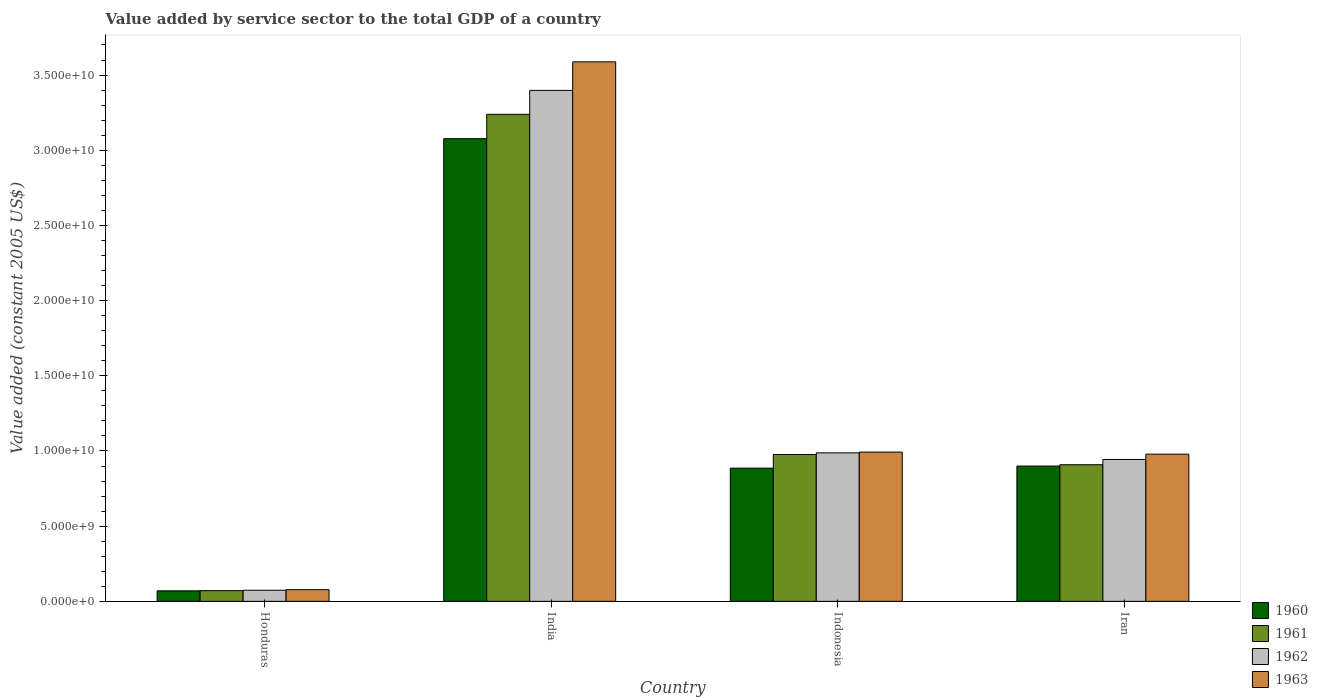How many different coloured bars are there?
Your response must be concise. 4. How many bars are there on the 2nd tick from the left?
Give a very brief answer. 4. How many bars are there on the 3rd tick from the right?
Ensure brevity in your answer.  4. What is the label of the 4th group of bars from the left?
Make the answer very short. Iran. What is the value added by service sector in 1962 in Honduras?
Keep it short and to the point. 7.41e+08. Across all countries, what is the maximum value added by service sector in 1960?
Provide a succinct answer. 3.08e+1. Across all countries, what is the minimum value added by service sector in 1961?
Your answer should be compact. 7.12e+08. In which country was the value added by service sector in 1960 minimum?
Make the answer very short. Honduras. What is the total value added by service sector in 1963 in the graph?
Give a very brief answer. 5.64e+1. What is the difference between the value added by service sector in 1960 in Honduras and that in India?
Provide a succinct answer. -3.01e+1. What is the difference between the value added by service sector in 1960 in India and the value added by service sector in 1961 in Honduras?
Your response must be concise. 3.01e+1. What is the average value added by service sector in 1960 per country?
Your answer should be compact. 1.23e+1. What is the difference between the value added by service sector of/in 1961 and value added by service sector of/in 1963 in Honduras?
Offer a terse response. -6.62e+07. In how many countries, is the value added by service sector in 1963 greater than 31000000000 US$?
Provide a succinct answer. 1. What is the ratio of the value added by service sector in 1961 in India to that in Iran?
Make the answer very short. 3.56. Is the value added by service sector in 1963 in Honduras less than that in Iran?
Provide a succinct answer. Yes. What is the difference between the highest and the second highest value added by service sector in 1961?
Your answer should be very brief. 2.26e+1. What is the difference between the highest and the lowest value added by service sector in 1963?
Offer a very short reply. 3.51e+1. In how many countries, is the value added by service sector in 1962 greater than the average value added by service sector in 1962 taken over all countries?
Provide a short and direct response. 1. What does the 3rd bar from the left in Honduras represents?
Your response must be concise. 1962. What does the 2nd bar from the right in Indonesia represents?
Offer a terse response. 1962. How many bars are there?
Make the answer very short. 16. What is the difference between two consecutive major ticks on the Y-axis?
Your answer should be compact. 5.00e+09. How many legend labels are there?
Make the answer very short. 4. How are the legend labels stacked?
Ensure brevity in your answer.  Vertical. What is the title of the graph?
Provide a short and direct response. Value added by service sector to the total GDP of a country. What is the label or title of the Y-axis?
Give a very brief answer. Value added (constant 2005 US$). What is the Value added (constant 2005 US$) of 1960 in Honduras?
Offer a terse response. 7.01e+08. What is the Value added (constant 2005 US$) of 1961 in Honduras?
Your answer should be very brief. 7.12e+08. What is the Value added (constant 2005 US$) in 1962 in Honduras?
Your answer should be compact. 7.41e+08. What is the Value added (constant 2005 US$) of 1963 in Honduras?
Give a very brief answer. 7.78e+08. What is the Value added (constant 2005 US$) in 1960 in India?
Offer a very short reply. 3.08e+1. What is the Value added (constant 2005 US$) of 1961 in India?
Your answer should be very brief. 3.24e+1. What is the Value added (constant 2005 US$) in 1962 in India?
Your response must be concise. 3.40e+1. What is the Value added (constant 2005 US$) of 1963 in India?
Offer a very short reply. 3.59e+1. What is the Value added (constant 2005 US$) in 1960 in Indonesia?
Ensure brevity in your answer.  8.86e+09. What is the Value added (constant 2005 US$) in 1961 in Indonesia?
Your response must be concise. 9.77e+09. What is the Value added (constant 2005 US$) of 1962 in Indonesia?
Give a very brief answer. 9.88e+09. What is the Value added (constant 2005 US$) in 1963 in Indonesia?
Keep it short and to the point. 9.93e+09. What is the Value added (constant 2005 US$) in 1960 in Iran?
Provide a short and direct response. 9.00e+09. What is the Value added (constant 2005 US$) of 1961 in Iran?
Your answer should be very brief. 9.09e+09. What is the Value added (constant 2005 US$) in 1962 in Iran?
Your answer should be very brief. 9.44e+09. What is the Value added (constant 2005 US$) of 1963 in Iran?
Offer a very short reply. 9.79e+09. Across all countries, what is the maximum Value added (constant 2005 US$) of 1960?
Ensure brevity in your answer.  3.08e+1. Across all countries, what is the maximum Value added (constant 2005 US$) in 1961?
Your answer should be very brief. 3.24e+1. Across all countries, what is the maximum Value added (constant 2005 US$) of 1962?
Provide a short and direct response. 3.40e+1. Across all countries, what is the maximum Value added (constant 2005 US$) in 1963?
Your response must be concise. 3.59e+1. Across all countries, what is the minimum Value added (constant 2005 US$) of 1960?
Your answer should be very brief. 7.01e+08. Across all countries, what is the minimum Value added (constant 2005 US$) in 1961?
Provide a succinct answer. 7.12e+08. Across all countries, what is the minimum Value added (constant 2005 US$) of 1962?
Offer a very short reply. 7.41e+08. Across all countries, what is the minimum Value added (constant 2005 US$) in 1963?
Offer a terse response. 7.78e+08. What is the total Value added (constant 2005 US$) of 1960 in the graph?
Make the answer very short. 4.93e+1. What is the total Value added (constant 2005 US$) in 1961 in the graph?
Make the answer very short. 5.20e+1. What is the total Value added (constant 2005 US$) in 1962 in the graph?
Your answer should be compact. 5.40e+1. What is the total Value added (constant 2005 US$) in 1963 in the graph?
Provide a short and direct response. 5.64e+1. What is the difference between the Value added (constant 2005 US$) in 1960 in Honduras and that in India?
Give a very brief answer. -3.01e+1. What is the difference between the Value added (constant 2005 US$) in 1961 in Honduras and that in India?
Your answer should be very brief. -3.17e+1. What is the difference between the Value added (constant 2005 US$) of 1962 in Honduras and that in India?
Offer a terse response. -3.32e+1. What is the difference between the Value added (constant 2005 US$) in 1963 in Honduras and that in India?
Provide a succinct answer. -3.51e+1. What is the difference between the Value added (constant 2005 US$) in 1960 in Honduras and that in Indonesia?
Give a very brief answer. -8.16e+09. What is the difference between the Value added (constant 2005 US$) in 1961 in Honduras and that in Indonesia?
Ensure brevity in your answer.  -9.05e+09. What is the difference between the Value added (constant 2005 US$) in 1962 in Honduras and that in Indonesia?
Your answer should be very brief. -9.13e+09. What is the difference between the Value added (constant 2005 US$) of 1963 in Honduras and that in Indonesia?
Offer a very short reply. -9.15e+09. What is the difference between the Value added (constant 2005 US$) in 1960 in Honduras and that in Iran?
Your response must be concise. -8.30e+09. What is the difference between the Value added (constant 2005 US$) in 1961 in Honduras and that in Iran?
Your answer should be compact. -8.37e+09. What is the difference between the Value added (constant 2005 US$) in 1962 in Honduras and that in Iran?
Your answer should be very brief. -8.70e+09. What is the difference between the Value added (constant 2005 US$) of 1963 in Honduras and that in Iran?
Give a very brief answer. -9.01e+09. What is the difference between the Value added (constant 2005 US$) of 1960 in India and that in Indonesia?
Offer a very short reply. 2.19e+1. What is the difference between the Value added (constant 2005 US$) in 1961 in India and that in Indonesia?
Your answer should be very brief. 2.26e+1. What is the difference between the Value added (constant 2005 US$) in 1962 in India and that in Indonesia?
Your response must be concise. 2.41e+1. What is the difference between the Value added (constant 2005 US$) in 1963 in India and that in Indonesia?
Offer a very short reply. 2.60e+1. What is the difference between the Value added (constant 2005 US$) of 1960 in India and that in Iran?
Make the answer very short. 2.18e+1. What is the difference between the Value added (constant 2005 US$) of 1961 in India and that in Iran?
Ensure brevity in your answer.  2.33e+1. What is the difference between the Value added (constant 2005 US$) in 1962 in India and that in Iran?
Provide a short and direct response. 2.45e+1. What is the difference between the Value added (constant 2005 US$) in 1963 in India and that in Iran?
Offer a very short reply. 2.61e+1. What is the difference between the Value added (constant 2005 US$) of 1960 in Indonesia and that in Iran?
Your answer should be very brief. -1.39e+08. What is the difference between the Value added (constant 2005 US$) of 1961 in Indonesia and that in Iran?
Provide a short and direct response. 6.80e+08. What is the difference between the Value added (constant 2005 US$) in 1962 in Indonesia and that in Iran?
Your answer should be very brief. 4.39e+08. What is the difference between the Value added (constant 2005 US$) of 1963 in Indonesia and that in Iran?
Give a very brief answer. 1.38e+08. What is the difference between the Value added (constant 2005 US$) of 1960 in Honduras and the Value added (constant 2005 US$) of 1961 in India?
Give a very brief answer. -3.17e+1. What is the difference between the Value added (constant 2005 US$) in 1960 in Honduras and the Value added (constant 2005 US$) in 1962 in India?
Your answer should be compact. -3.33e+1. What is the difference between the Value added (constant 2005 US$) of 1960 in Honduras and the Value added (constant 2005 US$) of 1963 in India?
Ensure brevity in your answer.  -3.52e+1. What is the difference between the Value added (constant 2005 US$) of 1961 in Honduras and the Value added (constant 2005 US$) of 1962 in India?
Ensure brevity in your answer.  -3.33e+1. What is the difference between the Value added (constant 2005 US$) in 1961 in Honduras and the Value added (constant 2005 US$) in 1963 in India?
Provide a short and direct response. -3.52e+1. What is the difference between the Value added (constant 2005 US$) of 1962 in Honduras and the Value added (constant 2005 US$) of 1963 in India?
Your response must be concise. -3.51e+1. What is the difference between the Value added (constant 2005 US$) of 1960 in Honduras and the Value added (constant 2005 US$) of 1961 in Indonesia?
Keep it short and to the point. -9.07e+09. What is the difference between the Value added (constant 2005 US$) in 1960 in Honduras and the Value added (constant 2005 US$) in 1962 in Indonesia?
Keep it short and to the point. -9.17e+09. What is the difference between the Value added (constant 2005 US$) in 1960 in Honduras and the Value added (constant 2005 US$) in 1963 in Indonesia?
Ensure brevity in your answer.  -9.23e+09. What is the difference between the Value added (constant 2005 US$) of 1961 in Honduras and the Value added (constant 2005 US$) of 1962 in Indonesia?
Give a very brief answer. -9.16e+09. What is the difference between the Value added (constant 2005 US$) in 1961 in Honduras and the Value added (constant 2005 US$) in 1963 in Indonesia?
Ensure brevity in your answer.  -9.22e+09. What is the difference between the Value added (constant 2005 US$) in 1962 in Honduras and the Value added (constant 2005 US$) in 1963 in Indonesia?
Offer a very short reply. -9.19e+09. What is the difference between the Value added (constant 2005 US$) in 1960 in Honduras and the Value added (constant 2005 US$) in 1961 in Iran?
Keep it short and to the point. -8.39e+09. What is the difference between the Value added (constant 2005 US$) of 1960 in Honduras and the Value added (constant 2005 US$) of 1962 in Iran?
Make the answer very short. -8.73e+09. What is the difference between the Value added (constant 2005 US$) in 1960 in Honduras and the Value added (constant 2005 US$) in 1963 in Iran?
Keep it short and to the point. -9.09e+09. What is the difference between the Value added (constant 2005 US$) of 1961 in Honduras and the Value added (constant 2005 US$) of 1962 in Iran?
Your response must be concise. -8.72e+09. What is the difference between the Value added (constant 2005 US$) in 1961 in Honduras and the Value added (constant 2005 US$) in 1963 in Iran?
Offer a terse response. -9.08e+09. What is the difference between the Value added (constant 2005 US$) of 1962 in Honduras and the Value added (constant 2005 US$) of 1963 in Iran?
Your answer should be compact. -9.05e+09. What is the difference between the Value added (constant 2005 US$) in 1960 in India and the Value added (constant 2005 US$) in 1961 in Indonesia?
Make the answer very short. 2.10e+1. What is the difference between the Value added (constant 2005 US$) of 1960 in India and the Value added (constant 2005 US$) of 1962 in Indonesia?
Your answer should be compact. 2.09e+1. What is the difference between the Value added (constant 2005 US$) of 1960 in India and the Value added (constant 2005 US$) of 1963 in Indonesia?
Provide a succinct answer. 2.08e+1. What is the difference between the Value added (constant 2005 US$) in 1961 in India and the Value added (constant 2005 US$) in 1962 in Indonesia?
Give a very brief answer. 2.25e+1. What is the difference between the Value added (constant 2005 US$) of 1961 in India and the Value added (constant 2005 US$) of 1963 in Indonesia?
Your response must be concise. 2.25e+1. What is the difference between the Value added (constant 2005 US$) of 1962 in India and the Value added (constant 2005 US$) of 1963 in Indonesia?
Your answer should be very brief. 2.41e+1. What is the difference between the Value added (constant 2005 US$) in 1960 in India and the Value added (constant 2005 US$) in 1961 in Iran?
Your answer should be very brief. 2.17e+1. What is the difference between the Value added (constant 2005 US$) of 1960 in India and the Value added (constant 2005 US$) of 1962 in Iran?
Provide a short and direct response. 2.13e+1. What is the difference between the Value added (constant 2005 US$) of 1960 in India and the Value added (constant 2005 US$) of 1963 in Iran?
Provide a succinct answer. 2.10e+1. What is the difference between the Value added (constant 2005 US$) of 1961 in India and the Value added (constant 2005 US$) of 1962 in Iran?
Provide a short and direct response. 2.30e+1. What is the difference between the Value added (constant 2005 US$) in 1961 in India and the Value added (constant 2005 US$) in 1963 in Iran?
Give a very brief answer. 2.26e+1. What is the difference between the Value added (constant 2005 US$) of 1962 in India and the Value added (constant 2005 US$) of 1963 in Iran?
Provide a succinct answer. 2.42e+1. What is the difference between the Value added (constant 2005 US$) of 1960 in Indonesia and the Value added (constant 2005 US$) of 1961 in Iran?
Your answer should be compact. -2.28e+08. What is the difference between the Value added (constant 2005 US$) in 1960 in Indonesia and the Value added (constant 2005 US$) in 1962 in Iran?
Provide a succinct answer. -5.77e+08. What is the difference between the Value added (constant 2005 US$) of 1960 in Indonesia and the Value added (constant 2005 US$) of 1963 in Iran?
Your answer should be compact. -9.30e+08. What is the difference between the Value added (constant 2005 US$) in 1961 in Indonesia and the Value added (constant 2005 US$) in 1962 in Iran?
Give a very brief answer. 3.30e+08. What is the difference between the Value added (constant 2005 US$) of 1961 in Indonesia and the Value added (constant 2005 US$) of 1963 in Iran?
Make the answer very short. -2.20e+07. What is the difference between the Value added (constant 2005 US$) of 1962 in Indonesia and the Value added (constant 2005 US$) of 1963 in Iran?
Provide a succinct answer. 8.67e+07. What is the average Value added (constant 2005 US$) in 1960 per country?
Provide a succinct answer. 1.23e+1. What is the average Value added (constant 2005 US$) in 1961 per country?
Make the answer very short. 1.30e+1. What is the average Value added (constant 2005 US$) in 1962 per country?
Your answer should be compact. 1.35e+1. What is the average Value added (constant 2005 US$) in 1963 per country?
Offer a terse response. 1.41e+1. What is the difference between the Value added (constant 2005 US$) of 1960 and Value added (constant 2005 US$) of 1961 in Honduras?
Your answer should be compact. -1.04e+07. What is the difference between the Value added (constant 2005 US$) of 1960 and Value added (constant 2005 US$) of 1962 in Honduras?
Make the answer very short. -3.93e+07. What is the difference between the Value added (constant 2005 US$) of 1960 and Value added (constant 2005 US$) of 1963 in Honduras?
Your answer should be very brief. -7.65e+07. What is the difference between the Value added (constant 2005 US$) in 1961 and Value added (constant 2005 US$) in 1962 in Honduras?
Offer a very short reply. -2.89e+07. What is the difference between the Value added (constant 2005 US$) of 1961 and Value added (constant 2005 US$) of 1963 in Honduras?
Your response must be concise. -6.62e+07. What is the difference between the Value added (constant 2005 US$) of 1962 and Value added (constant 2005 US$) of 1963 in Honduras?
Provide a short and direct response. -3.72e+07. What is the difference between the Value added (constant 2005 US$) of 1960 and Value added (constant 2005 US$) of 1961 in India?
Make the answer very short. -1.62e+09. What is the difference between the Value added (constant 2005 US$) in 1960 and Value added (constant 2005 US$) in 1962 in India?
Give a very brief answer. -3.21e+09. What is the difference between the Value added (constant 2005 US$) in 1960 and Value added (constant 2005 US$) in 1963 in India?
Provide a short and direct response. -5.11e+09. What is the difference between the Value added (constant 2005 US$) in 1961 and Value added (constant 2005 US$) in 1962 in India?
Ensure brevity in your answer.  -1.59e+09. What is the difference between the Value added (constant 2005 US$) in 1961 and Value added (constant 2005 US$) in 1963 in India?
Give a very brief answer. -3.49e+09. What is the difference between the Value added (constant 2005 US$) of 1962 and Value added (constant 2005 US$) of 1963 in India?
Your response must be concise. -1.90e+09. What is the difference between the Value added (constant 2005 US$) of 1960 and Value added (constant 2005 US$) of 1961 in Indonesia?
Keep it short and to the point. -9.08e+08. What is the difference between the Value added (constant 2005 US$) in 1960 and Value added (constant 2005 US$) in 1962 in Indonesia?
Provide a short and direct response. -1.02e+09. What is the difference between the Value added (constant 2005 US$) of 1960 and Value added (constant 2005 US$) of 1963 in Indonesia?
Your answer should be very brief. -1.07e+09. What is the difference between the Value added (constant 2005 US$) of 1961 and Value added (constant 2005 US$) of 1962 in Indonesia?
Make the answer very short. -1.09e+08. What is the difference between the Value added (constant 2005 US$) of 1961 and Value added (constant 2005 US$) of 1963 in Indonesia?
Offer a terse response. -1.60e+08. What is the difference between the Value added (constant 2005 US$) in 1962 and Value added (constant 2005 US$) in 1963 in Indonesia?
Ensure brevity in your answer.  -5.15e+07. What is the difference between the Value added (constant 2005 US$) in 1960 and Value added (constant 2005 US$) in 1961 in Iran?
Make the answer very short. -8.88e+07. What is the difference between the Value added (constant 2005 US$) of 1960 and Value added (constant 2005 US$) of 1962 in Iran?
Offer a very short reply. -4.39e+08. What is the difference between the Value added (constant 2005 US$) in 1960 and Value added (constant 2005 US$) in 1963 in Iran?
Ensure brevity in your answer.  -7.91e+08. What is the difference between the Value added (constant 2005 US$) in 1961 and Value added (constant 2005 US$) in 1962 in Iran?
Provide a succinct answer. -3.50e+08. What is the difference between the Value added (constant 2005 US$) in 1961 and Value added (constant 2005 US$) in 1963 in Iran?
Keep it short and to the point. -7.02e+08. What is the difference between the Value added (constant 2005 US$) in 1962 and Value added (constant 2005 US$) in 1963 in Iran?
Offer a terse response. -3.52e+08. What is the ratio of the Value added (constant 2005 US$) in 1960 in Honduras to that in India?
Give a very brief answer. 0.02. What is the ratio of the Value added (constant 2005 US$) of 1961 in Honduras to that in India?
Provide a short and direct response. 0.02. What is the ratio of the Value added (constant 2005 US$) in 1962 in Honduras to that in India?
Give a very brief answer. 0.02. What is the ratio of the Value added (constant 2005 US$) in 1963 in Honduras to that in India?
Your response must be concise. 0.02. What is the ratio of the Value added (constant 2005 US$) of 1960 in Honduras to that in Indonesia?
Offer a very short reply. 0.08. What is the ratio of the Value added (constant 2005 US$) in 1961 in Honduras to that in Indonesia?
Provide a short and direct response. 0.07. What is the ratio of the Value added (constant 2005 US$) of 1962 in Honduras to that in Indonesia?
Ensure brevity in your answer.  0.07. What is the ratio of the Value added (constant 2005 US$) of 1963 in Honduras to that in Indonesia?
Offer a very short reply. 0.08. What is the ratio of the Value added (constant 2005 US$) in 1960 in Honduras to that in Iran?
Provide a short and direct response. 0.08. What is the ratio of the Value added (constant 2005 US$) in 1961 in Honduras to that in Iran?
Ensure brevity in your answer.  0.08. What is the ratio of the Value added (constant 2005 US$) in 1962 in Honduras to that in Iran?
Your answer should be compact. 0.08. What is the ratio of the Value added (constant 2005 US$) of 1963 in Honduras to that in Iran?
Provide a succinct answer. 0.08. What is the ratio of the Value added (constant 2005 US$) of 1960 in India to that in Indonesia?
Offer a very short reply. 3.47. What is the ratio of the Value added (constant 2005 US$) of 1961 in India to that in Indonesia?
Your response must be concise. 3.32. What is the ratio of the Value added (constant 2005 US$) of 1962 in India to that in Indonesia?
Ensure brevity in your answer.  3.44. What is the ratio of the Value added (constant 2005 US$) in 1963 in India to that in Indonesia?
Make the answer very short. 3.61. What is the ratio of the Value added (constant 2005 US$) in 1960 in India to that in Iran?
Your answer should be very brief. 3.42. What is the ratio of the Value added (constant 2005 US$) in 1961 in India to that in Iran?
Provide a succinct answer. 3.56. What is the ratio of the Value added (constant 2005 US$) of 1962 in India to that in Iran?
Keep it short and to the point. 3.6. What is the ratio of the Value added (constant 2005 US$) of 1963 in India to that in Iran?
Your response must be concise. 3.67. What is the ratio of the Value added (constant 2005 US$) in 1960 in Indonesia to that in Iran?
Keep it short and to the point. 0.98. What is the ratio of the Value added (constant 2005 US$) in 1961 in Indonesia to that in Iran?
Offer a very short reply. 1.07. What is the ratio of the Value added (constant 2005 US$) of 1962 in Indonesia to that in Iran?
Your answer should be very brief. 1.05. What is the ratio of the Value added (constant 2005 US$) of 1963 in Indonesia to that in Iran?
Your answer should be very brief. 1.01. What is the difference between the highest and the second highest Value added (constant 2005 US$) of 1960?
Your answer should be very brief. 2.18e+1. What is the difference between the highest and the second highest Value added (constant 2005 US$) of 1961?
Provide a succinct answer. 2.26e+1. What is the difference between the highest and the second highest Value added (constant 2005 US$) of 1962?
Ensure brevity in your answer.  2.41e+1. What is the difference between the highest and the second highest Value added (constant 2005 US$) of 1963?
Offer a terse response. 2.60e+1. What is the difference between the highest and the lowest Value added (constant 2005 US$) in 1960?
Your response must be concise. 3.01e+1. What is the difference between the highest and the lowest Value added (constant 2005 US$) of 1961?
Offer a very short reply. 3.17e+1. What is the difference between the highest and the lowest Value added (constant 2005 US$) of 1962?
Give a very brief answer. 3.32e+1. What is the difference between the highest and the lowest Value added (constant 2005 US$) of 1963?
Offer a terse response. 3.51e+1. 